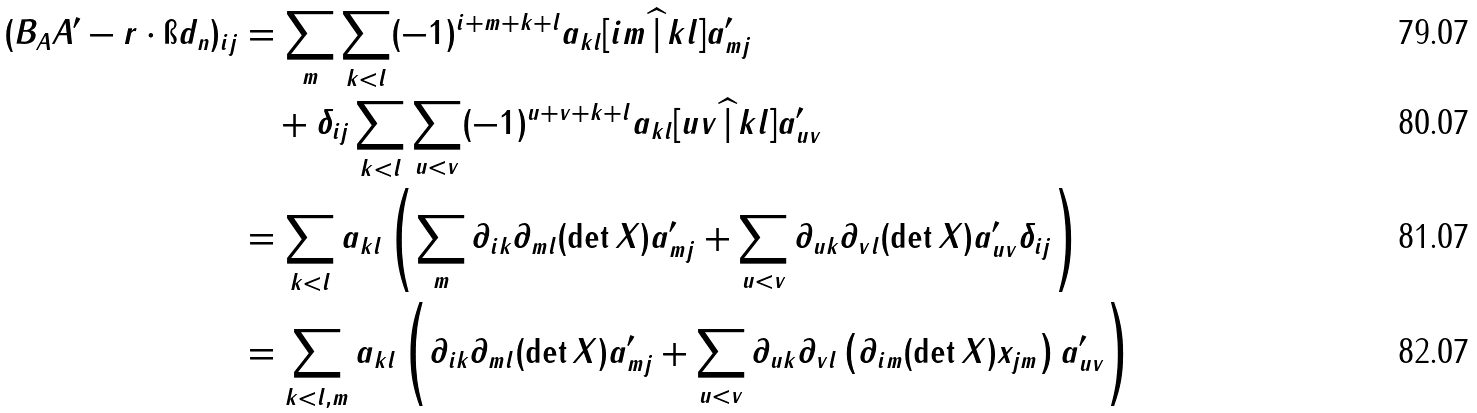Convert formula to latex. <formula><loc_0><loc_0><loc_500><loc_500>( B _ { A } A ^ { \prime } - r \cdot \i d _ { n } ) _ { i j } & = \sum _ { m } \sum _ { k < l } ( - 1 ) ^ { i + m + k + l } a _ { k l } [ i m \, \widehat { | } \, k l ] a ^ { \prime } _ { m j } \\ & \quad + \delta _ { i j } \sum _ { k < l } \sum _ { u < v } ( - 1 ) ^ { u + v + k + l } a _ { k l } [ u v \, \widehat { | } \, k l ] a ^ { \prime } _ { u v } \\ & = \sum _ { k < l } a _ { k l } \left ( \sum _ { m } \partial _ { i k } \partial _ { m l } ( \det X ) a ^ { \prime } _ { m j } + \sum _ { u < v } \partial _ { u k } \partial _ { v l } ( \det X ) a ^ { \prime } _ { u v } \delta _ { i j } \right ) \\ & = \sum _ { k < l , m } a _ { k l } \left ( \partial _ { i k } \partial _ { m l } ( \det X ) a ^ { \prime } _ { m j } + \sum _ { u < v } \partial _ { u k } \partial _ { v l } \left ( \partial _ { i m } ( \det X ) x _ { j m } \right ) a ^ { \prime } _ { u v } \right )</formula> 